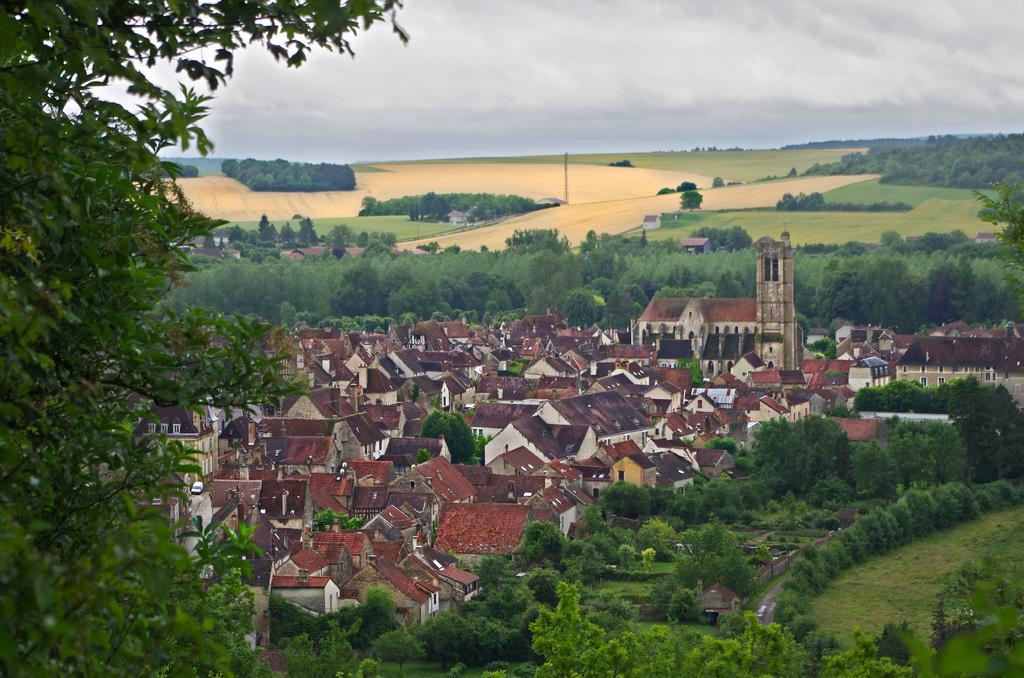In one or two sentences, can you explain what this image depicts? In this image at the bottom, there are houses, trees, plants, grass. In the middle there are crops, trees, sky and clouds. 